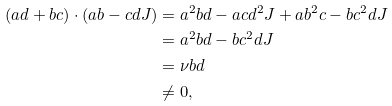Convert formula to latex. <formula><loc_0><loc_0><loc_500><loc_500>( a d + b c ) \cdot ( a b - c d J ) & = a ^ { 2 } b d - a c d ^ { 2 } J + a b ^ { 2 } c - b c ^ { 2 } d J \\ & = a ^ { 2 } b d - b c ^ { 2 } d J \\ & = \nu b d \\ & \ne 0 ,</formula> 